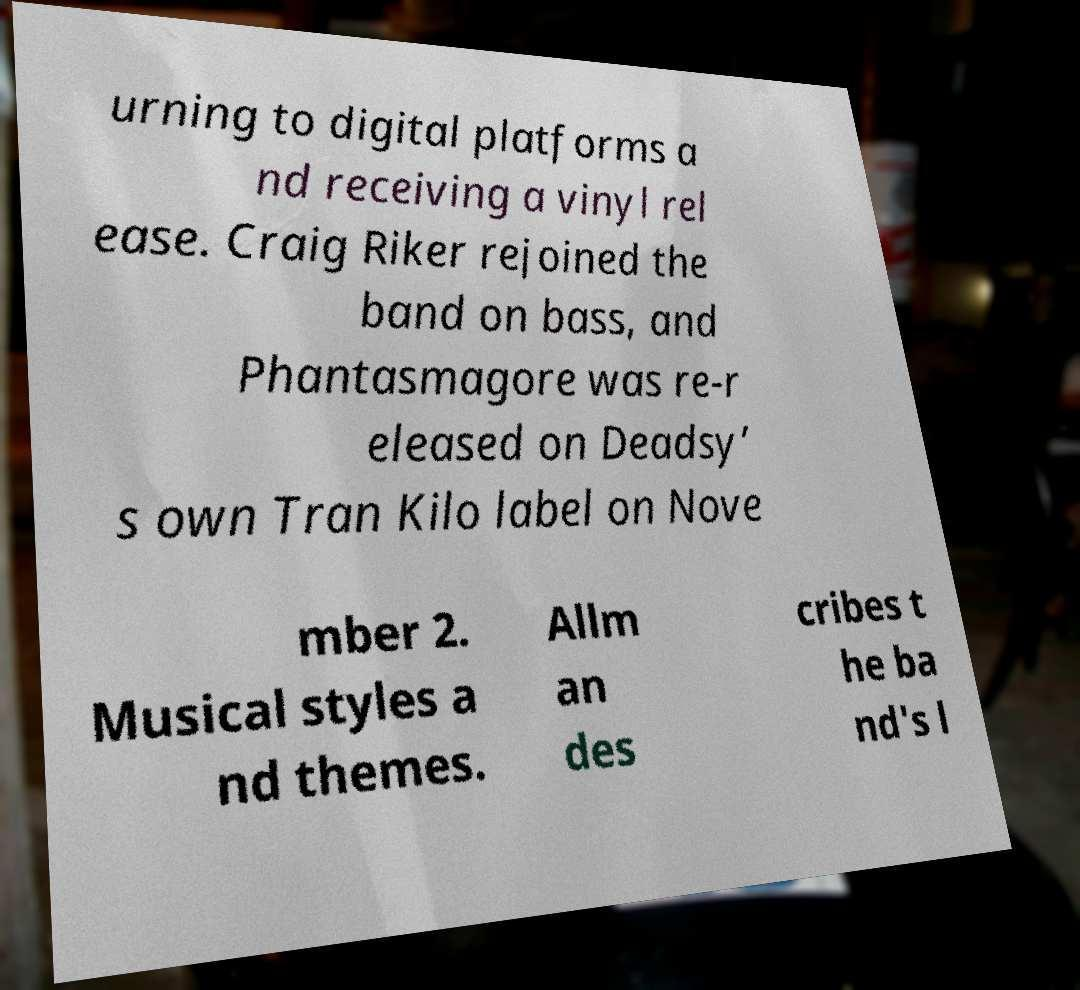Please identify and transcribe the text found in this image. urning to digital platforms a nd receiving a vinyl rel ease. Craig Riker rejoined the band on bass, and Phantasmagore was re-r eleased on Deadsy’ s own Tran Kilo label on Nove mber 2. Musical styles a nd themes. Allm an des cribes t he ba nd's l 